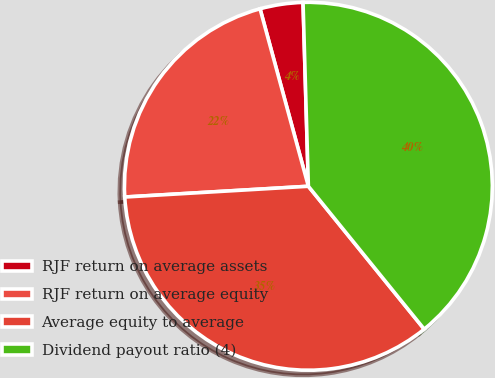<chart> <loc_0><loc_0><loc_500><loc_500><pie_chart><fcel>RJF return on average assets<fcel>RJF return on average equity<fcel>Average equity to average<fcel>Dividend payout ratio (4)<nl><fcel>3.77%<fcel>21.7%<fcel>34.91%<fcel>39.62%<nl></chart> 